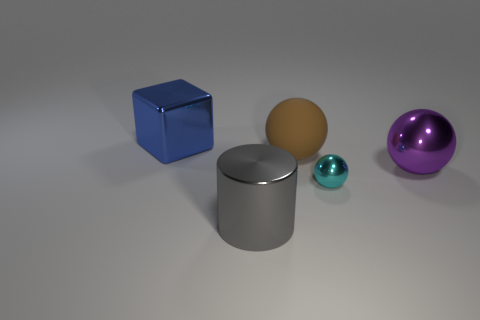Is there any other thing that is the same size as the cyan metallic object?
Keep it short and to the point. No. Does the thing behind the big matte object have the same size as the metal sphere that is behind the tiny thing?
Your answer should be very brief. Yes. The big metal object that is on the left side of the shiny thing that is in front of the cyan thing is what shape?
Offer a terse response. Cube. There is a cube; is its size the same as the metallic ball that is to the left of the purple metal ball?
Provide a short and direct response. No. What is the size of the shiny ball left of the big metal thing that is to the right of the small thing right of the big gray shiny thing?
Provide a short and direct response. Small. What number of things are either things that are on the right side of the small metal object or large gray balls?
Your answer should be very brief. 1. What number of purple metallic balls are on the right side of the big metallic object that is in front of the purple shiny thing?
Provide a short and direct response. 1. Is the number of purple balls that are behind the big cylinder greater than the number of tiny brown things?
Provide a short and direct response. Yes. There is a thing that is both in front of the big metallic sphere and right of the metal cylinder; what size is it?
Your response must be concise. Small. What shape is the big object that is behind the small cyan metal ball and in front of the brown rubber thing?
Provide a short and direct response. Sphere. 